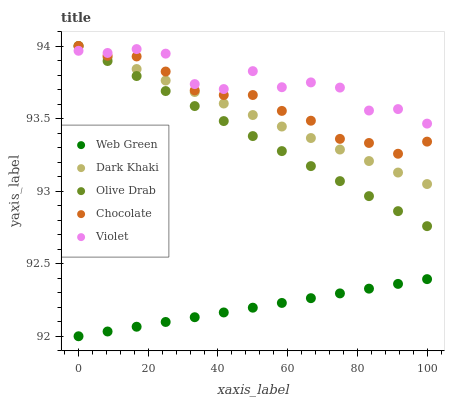Does Web Green have the minimum area under the curve?
Answer yes or no. Yes. Does Violet have the maximum area under the curve?
Answer yes or no. Yes. Does Olive Drab have the minimum area under the curve?
Answer yes or no. No. Does Olive Drab have the maximum area under the curve?
Answer yes or no. No. Is Dark Khaki the smoothest?
Answer yes or no. Yes. Is Violet the roughest?
Answer yes or no. Yes. Is Olive Drab the smoothest?
Answer yes or no. No. Is Olive Drab the roughest?
Answer yes or no. No. Does Web Green have the lowest value?
Answer yes or no. Yes. Does Olive Drab have the lowest value?
Answer yes or no. No. Does Chocolate have the highest value?
Answer yes or no. Yes. Does Violet have the highest value?
Answer yes or no. No. Is Web Green less than Olive Drab?
Answer yes or no. Yes. Is Dark Khaki greater than Web Green?
Answer yes or no. Yes. Does Dark Khaki intersect Chocolate?
Answer yes or no. Yes. Is Dark Khaki less than Chocolate?
Answer yes or no. No. Is Dark Khaki greater than Chocolate?
Answer yes or no. No. Does Web Green intersect Olive Drab?
Answer yes or no. No. 